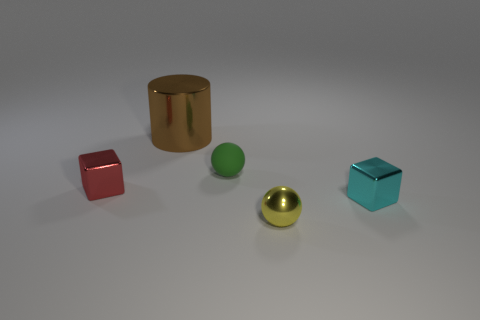Add 4 brown things. How many objects exist? 9 Subtract 2 blocks. How many blocks are left? 0 Subtract all blocks. How many objects are left? 3 Add 3 tiny green cylinders. How many tiny green cylinders exist? 3 Subtract 0 cyan cylinders. How many objects are left? 5 Subtract all blue cubes. Subtract all red balls. How many cubes are left? 2 Subtract all gray blocks. How many purple cylinders are left? 0 Subtract all cyan metallic objects. Subtract all small red cubes. How many objects are left? 3 Add 1 cylinders. How many cylinders are left? 2 